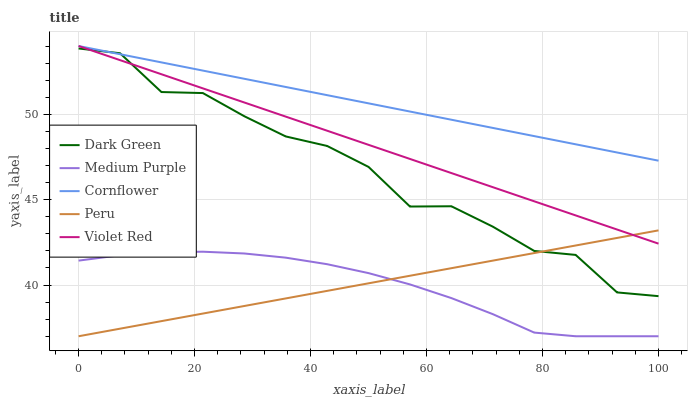Does Medium Purple have the minimum area under the curve?
Answer yes or no. Yes. Does Cornflower have the maximum area under the curve?
Answer yes or no. Yes. Does Violet Red have the minimum area under the curve?
Answer yes or no. No. Does Violet Red have the maximum area under the curve?
Answer yes or no. No. Is Violet Red the smoothest?
Answer yes or no. Yes. Is Dark Green the roughest?
Answer yes or no. Yes. Is Cornflower the smoothest?
Answer yes or no. No. Is Cornflower the roughest?
Answer yes or no. No. Does Medium Purple have the lowest value?
Answer yes or no. Yes. Does Violet Red have the lowest value?
Answer yes or no. No. Does Violet Red have the highest value?
Answer yes or no. Yes. Does Peru have the highest value?
Answer yes or no. No. Is Peru less than Cornflower?
Answer yes or no. Yes. Is Cornflower greater than Medium Purple?
Answer yes or no. Yes. Does Peru intersect Dark Green?
Answer yes or no. Yes. Is Peru less than Dark Green?
Answer yes or no. No. Is Peru greater than Dark Green?
Answer yes or no. No. Does Peru intersect Cornflower?
Answer yes or no. No. 